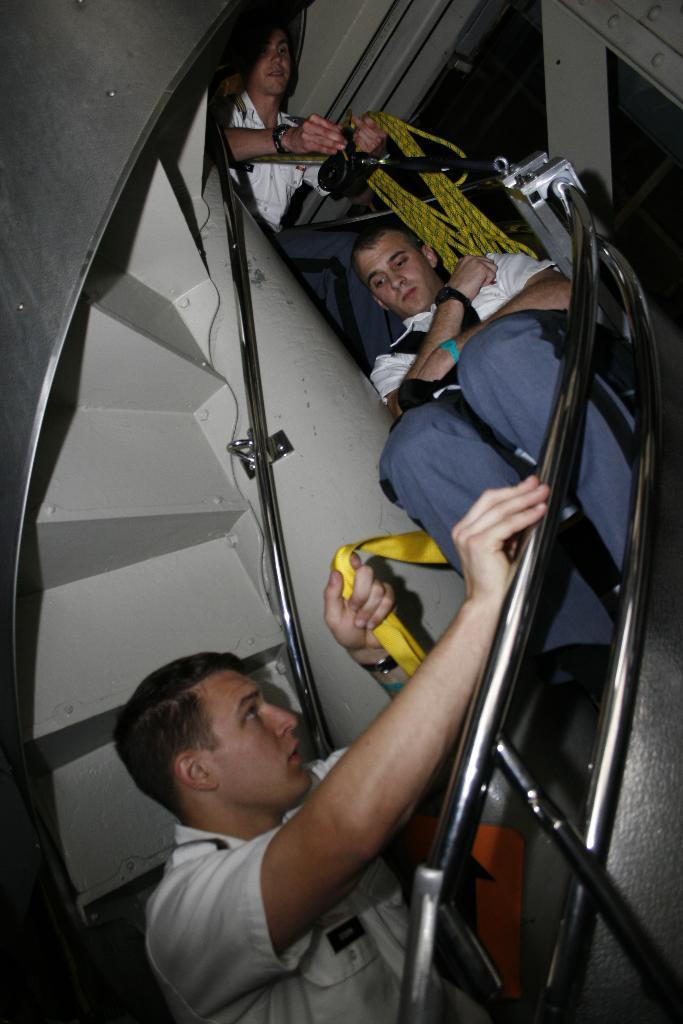How many people are in the image? There are three men in the image. What are the men doing in the image? The men are riding on stairs. Can you describe the attire of the second man? The second man is wearing a white shirt and blue pants. What is the top man holding in the image? The top man is holding a rope. What type of appliance is the son using in the image? There is no son or appliance present in the image. 